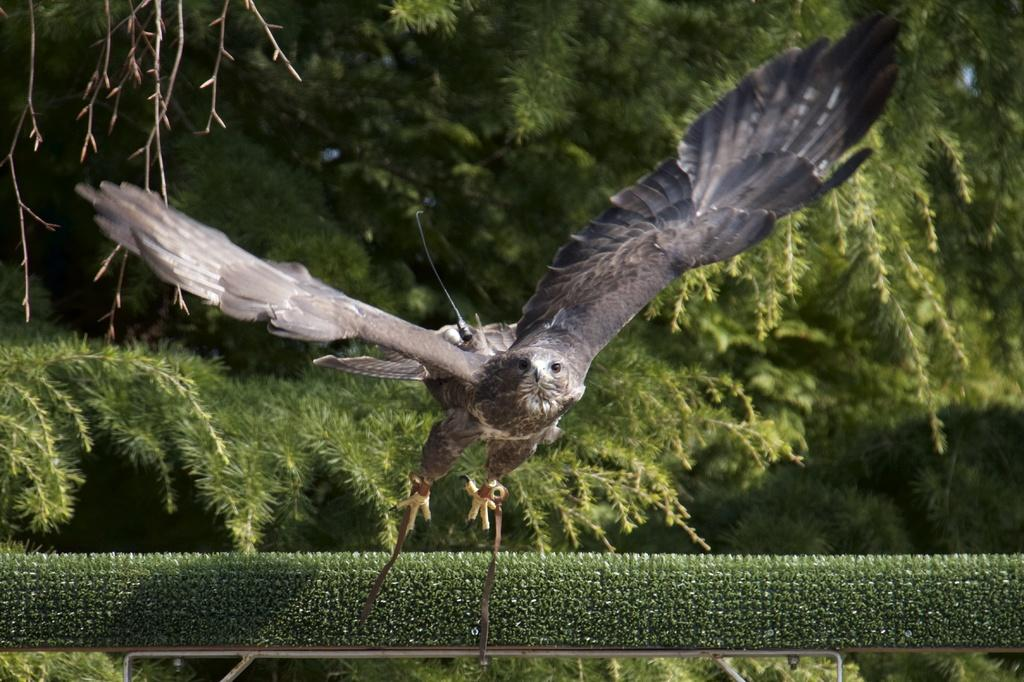What animal is the main subject of the image? There is an eagle in the image. What is the eagle doing in the image? The eagle is flying in the image. What can be seen in the background of the image? There is a fence, plants, and trees in the background of the image. What type of flower is the eagle holding in its talons in the image? There is no flower present in the image; the eagle is flying without holding anything. What does the image smell like? The image does not have a smell, as it is a visual representation and not a physical object. 